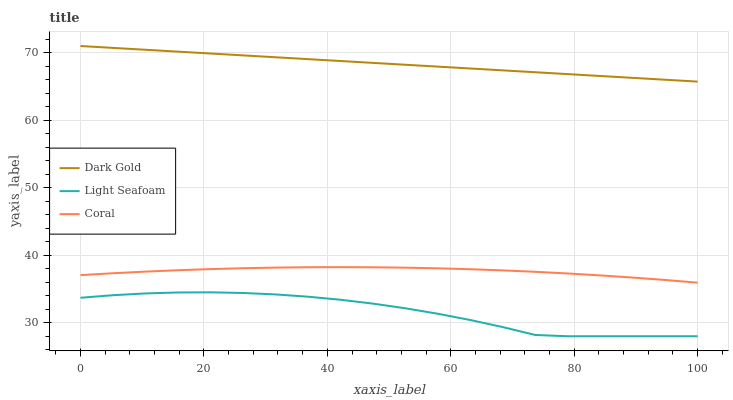Does Light Seafoam have the minimum area under the curve?
Answer yes or no. Yes. Does Dark Gold have the maximum area under the curve?
Answer yes or no. Yes. Does Dark Gold have the minimum area under the curve?
Answer yes or no. No. Does Light Seafoam have the maximum area under the curve?
Answer yes or no. No. Is Dark Gold the smoothest?
Answer yes or no. Yes. Is Light Seafoam the roughest?
Answer yes or no. Yes. Is Light Seafoam the smoothest?
Answer yes or no. No. Is Dark Gold the roughest?
Answer yes or no. No. Does Light Seafoam have the lowest value?
Answer yes or no. Yes. Does Dark Gold have the lowest value?
Answer yes or no. No. Does Dark Gold have the highest value?
Answer yes or no. Yes. Does Light Seafoam have the highest value?
Answer yes or no. No. Is Light Seafoam less than Dark Gold?
Answer yes or no. Yes. Is Dark Gold greater than Coral?
Answer yes or no. Yes. Does Light Seafoam intersect Dark Gold?
Answer yes or no. No. 